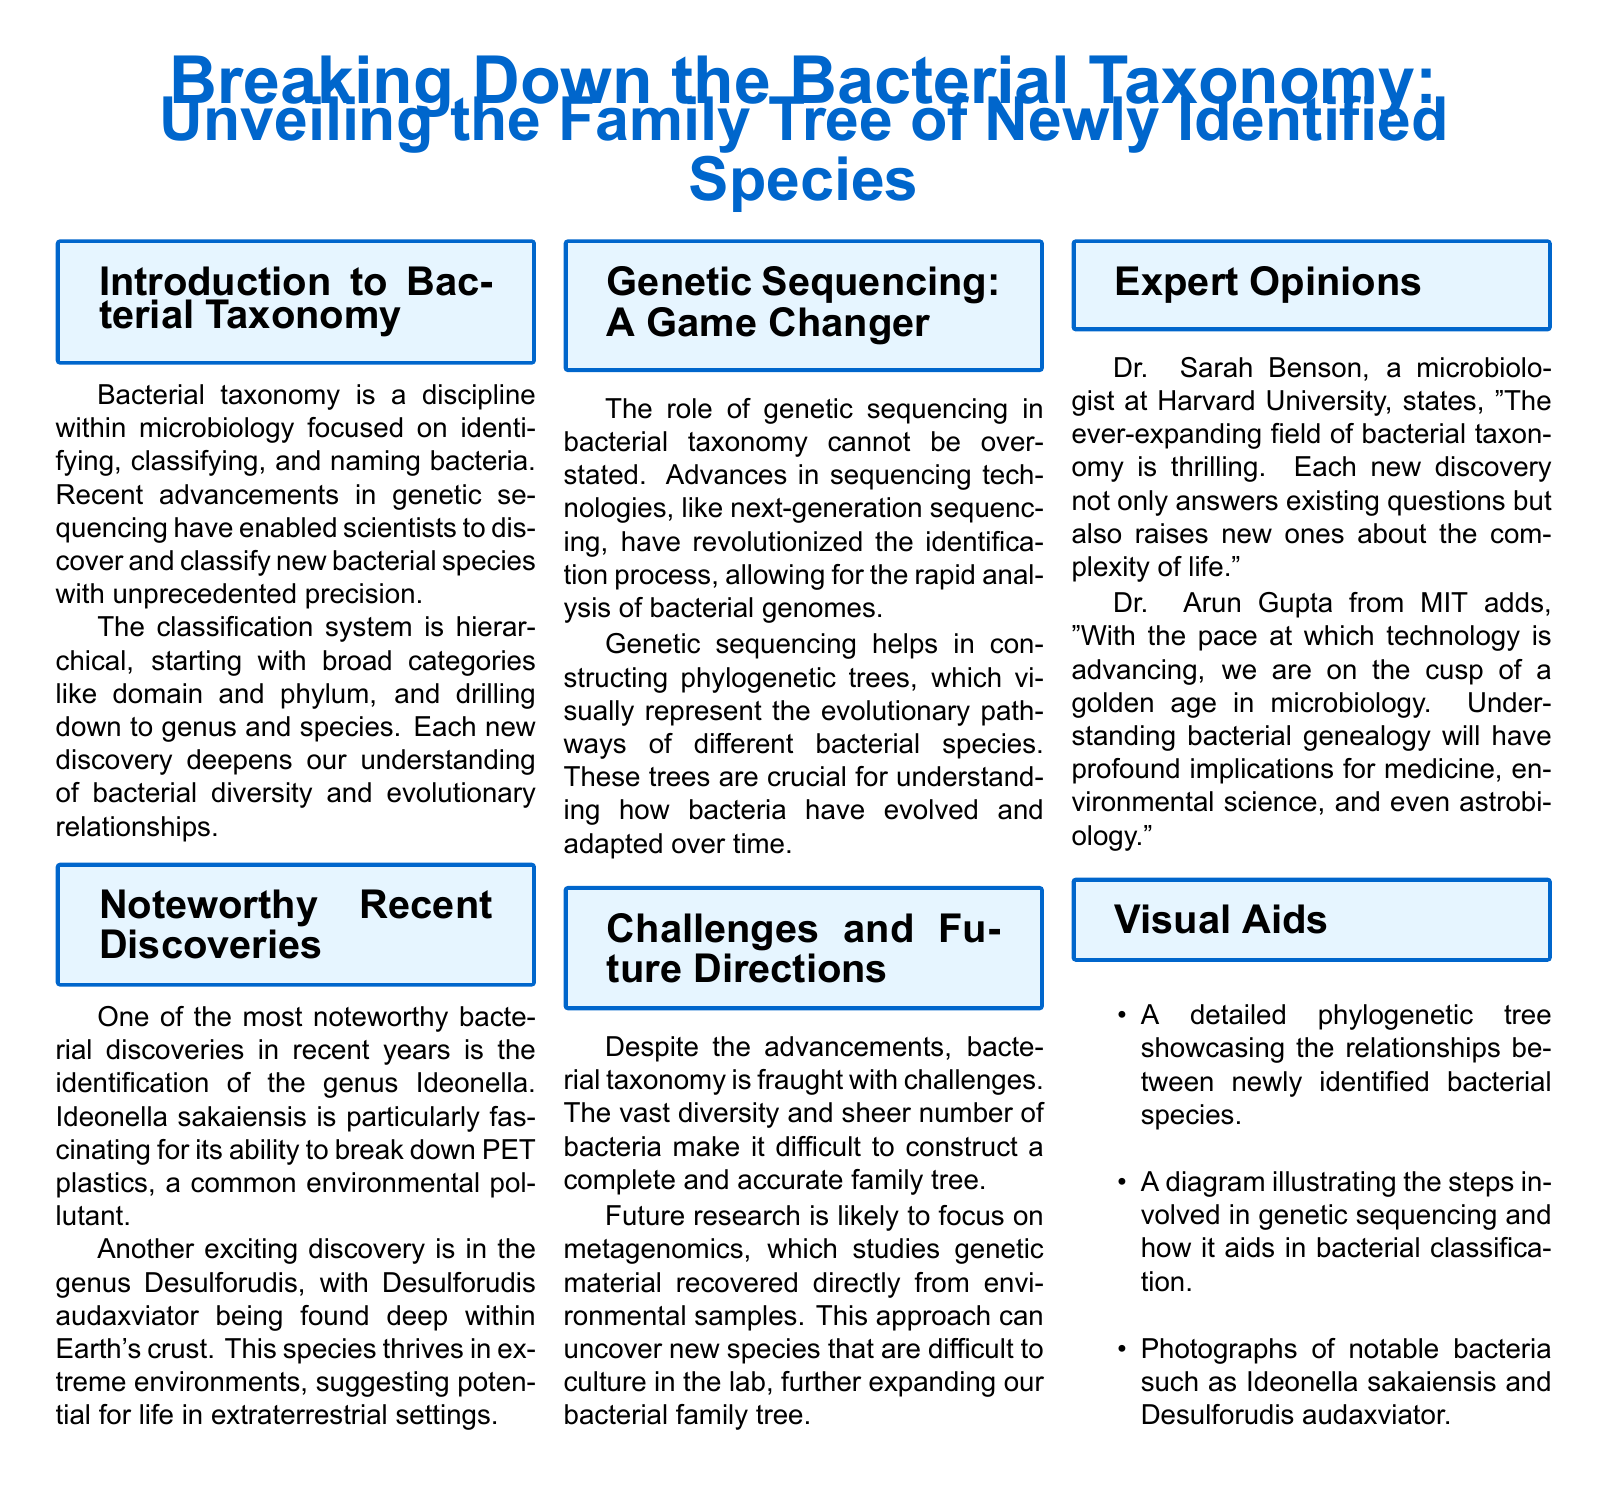What is the primary focus of bacterial taxonomy? The document states that bacterial taxonomy is focused on identifying, classifying, and naming bacteria.
Answer: Identifying, classifying, and naming bacteria Which genus is noted for breaking down PET plastics? Ideonella sakaiensis is cited in the document for its ability to break down PET plastics.
Answer: Ideonella What is a significant benefit of genetic sequencing in bacterial taxonomy? The document mentions that genetic sequencing allows for the rapid analysis of bacterial genomes, aiding in bacterial identification.
Answer: Rapid analysis of bacterial genomes Who provided the quote regarding the exciting field of bacterial taxonomy? Dr. Sarah Benson from Harvard University is the one quoted about the exciting field of bacterial taxonomy.
Answer: Dr. Sarah Benson What is a challenge mentioned in the document regarding bacterial taxonomy? The vast diversity and number of bacteria present a challenge in constructing a complete family tree.
Answer: Vast diversity and number of bacteria What type of research is likely to be emphasized in the future? The document indicates that future research will likely focus on metagenomics.
Answer: Metagenomics Which bacterial species is found deep within Earth's crust? Desulforudis audaxviator is mentioned as being found deep within Earth's crust.
Answer: Desulforudis audaxviator What visually represents the evolutionary pathways of different bacterial species? Phylogenetic trees visually represent the evolutionary pathways of bacterial species as referenced in the document.
Answer: Phylogenetic trees 